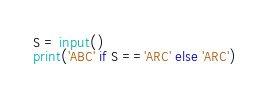<code> <loc_0><loc_0><loc_500><loc_500><_Python_>S = input()
print('ABC' if S =='ARC' else 'ARC')</code> 